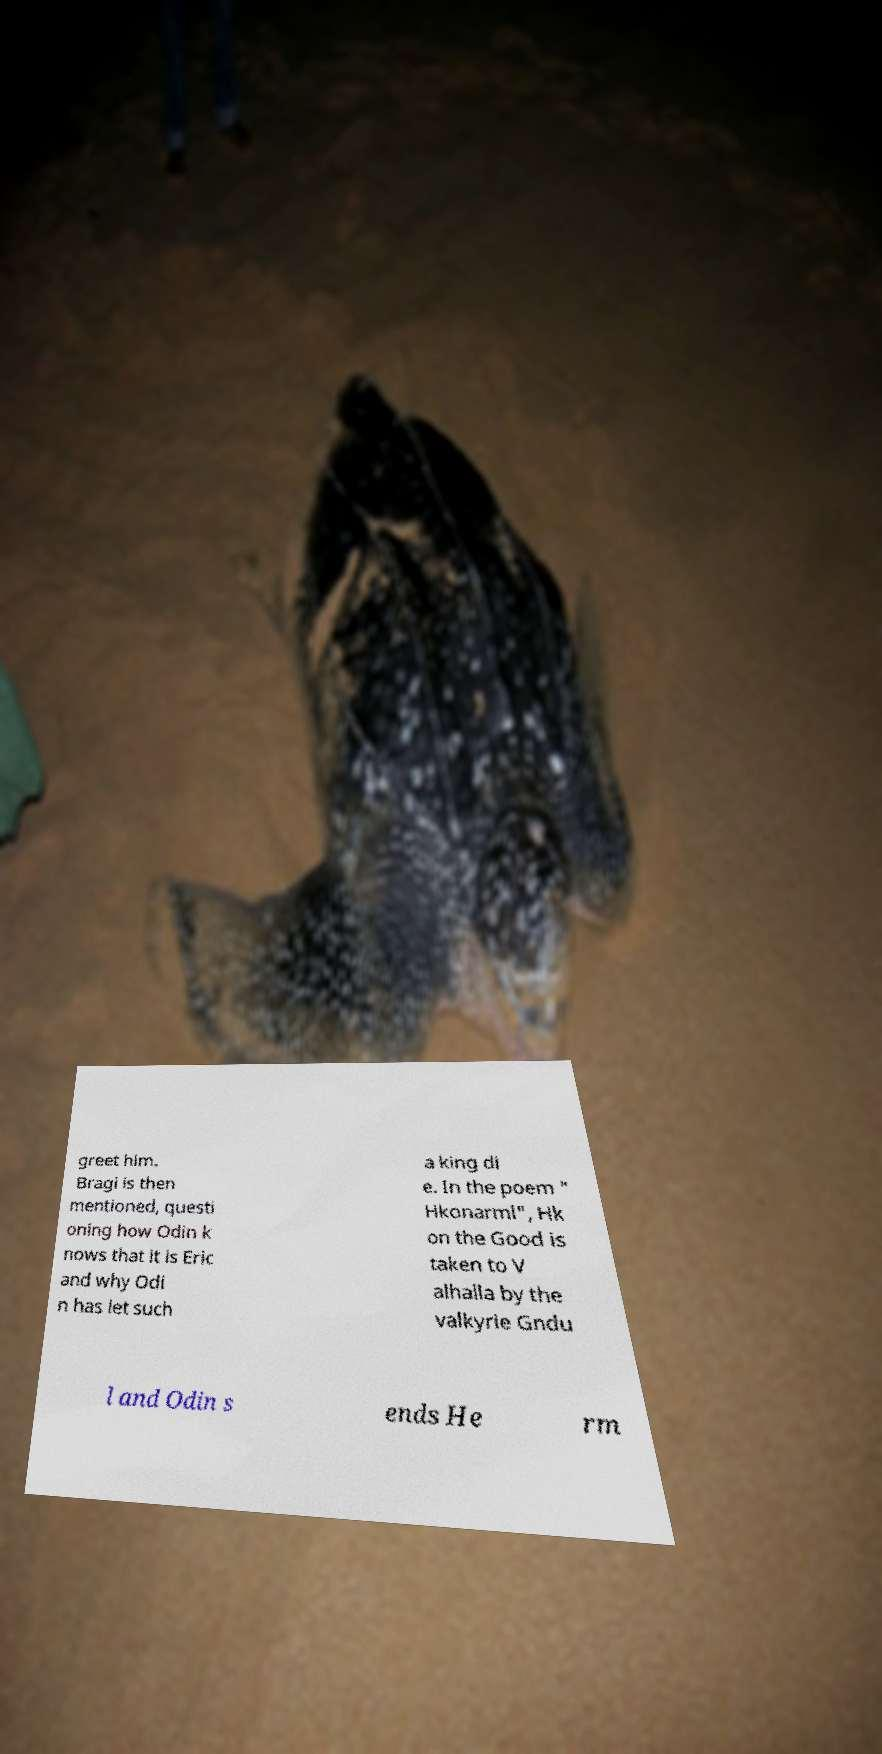Please read and relay the text visible in this image. What does it say? greet him. Bragi is then mentioned, questi oning how Odin k nows that it is Eric and why Odi n has let such a king di e. In the poem " Hkonarml", Hk on the Good is taken to V alhalla by the valkyrie Gndu l and Odin s ends He rm 